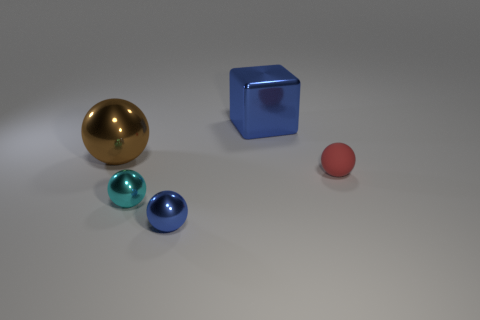Add 1 large balls. How many objects exist? 6 Subtract all cubes. How many objects are left? 4 Subtract all brown rubber cubes. Subtract all metal spheres. How many objects are left? 2 Add 2 tiny cyan balls. How many tiny cyan balls are left? 3 Add 5 green cylinders. How many green cylinders exist? 5 Subtract 1 blue blocks. How many objects are left? 4 